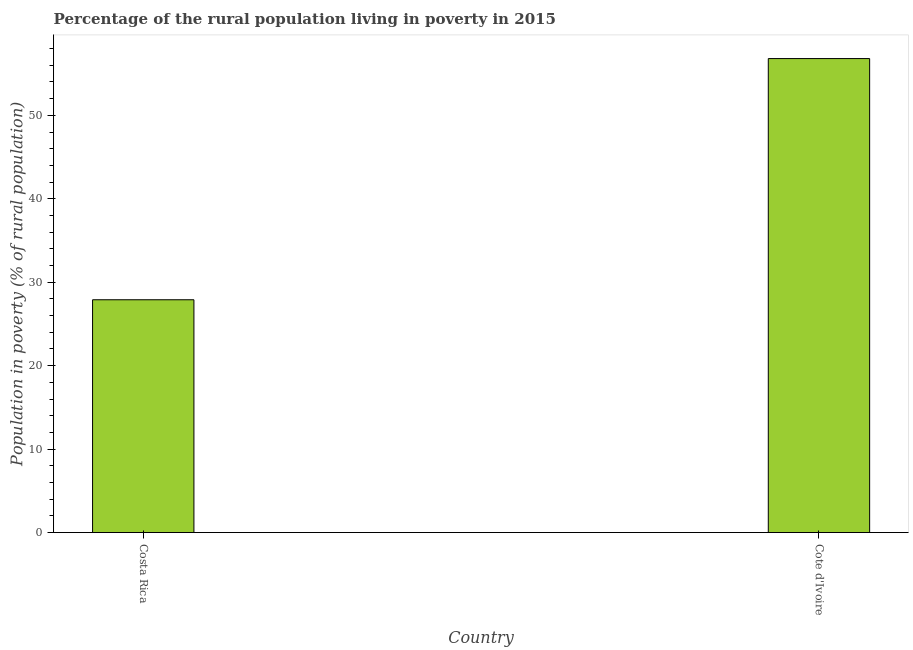Does the graph contain any zero values?
Offer a very short reply. No. Does the graph contain grids?
Your response must be concise. No. What is the title of the graph?
Provide a short and direct response. Percentage of the rural population living in poverty in 2015. What is the label or title of the X-axis?
Ensure brevity in your answer.  Country. What is the label or title of the Y-axis?
Make the answer very short. Population in poverty (% of rural population). What is the percentage of rural population living below poverty line in Costa Rica?
Ensure brevity in your answer.  27.9. Across all countries, what is the maximum percentage of rural population living below poverty line?
Your answer should be compact. 56.8. Across all countries, what is the minimum percentage of rural population living below poverty line?
Your answer should be very brief. 27.9. In which country was the percentage of rural population living below poverty line maximum?
Provide a succinct answer. Cote d'Ivoire. In which country was the percentage of rural population living below poverty line minimum?
Make the answer very short. Costa Rica. What is the sum of the percentage of rural population living below poverty line?
Provide a short and direct response. 84.7. What is the difference between the percentage of rural population living below poverty line in Costa Rica and Cote d'Ivoire?
Provide a succinct answer. -28.9. What is the average percentage of rural population living below poverty line per country?
Your response must be concise. 42.35. What is the median percentage of rural population living below poverty line?
Provide a succinct answer. 42.35. In how many countries, is the percentage of rural population living below poverty line greater than 22 %?
Your answer should be compact. 2. What is the ratio of the percentage of rural population living below poverty line in Costa Rica to that in Cote d'Ivoire?
Provide a succinct answer. 0.49. Are all the bars in the graph horizontal?
Make the answer very short. No. What is the difference between two consecutive major ticks on the Y-axis?
Offer a very short reply. 10. Are the values on the major ticks of Y-axis written in scientific E-notation?
Your answer should be compact. No. What is the Population in poverty (% of rural population) of Costa Rica?
Your response must be concise. 27.9. What is the Population in poverty (% of rural population) of Cote d'Ivoire?
Keep it short and to the point. 56.8. What is the difference between the Population in poverty (% of rural population) in Costa Rica and Cote d'Ivoire?
Ensure brevity in your answer.  -28.9. What is the ratio of the Population in poverty (% of rural population) in Costa Rica to that in Cote d'Ivoire?
Offer a terse response. 0.49. 